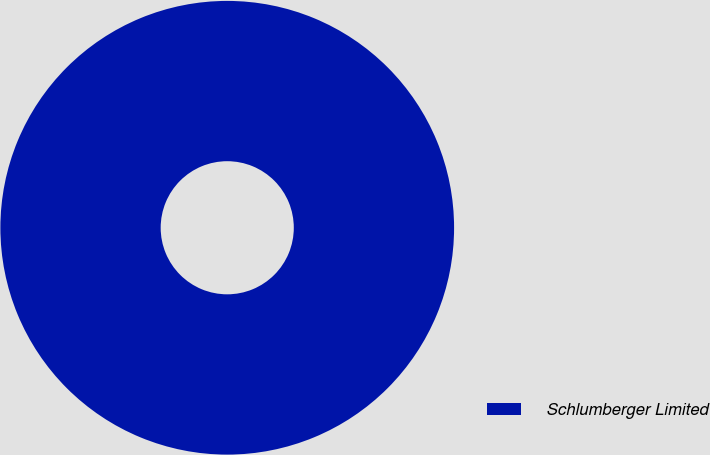Convert chart. <chart><loc_0><loc_0><loc_500><loc_500><pie_chart><fcel>Schlumberger Limited<nl><fcel>100.0%<nl></chart> 